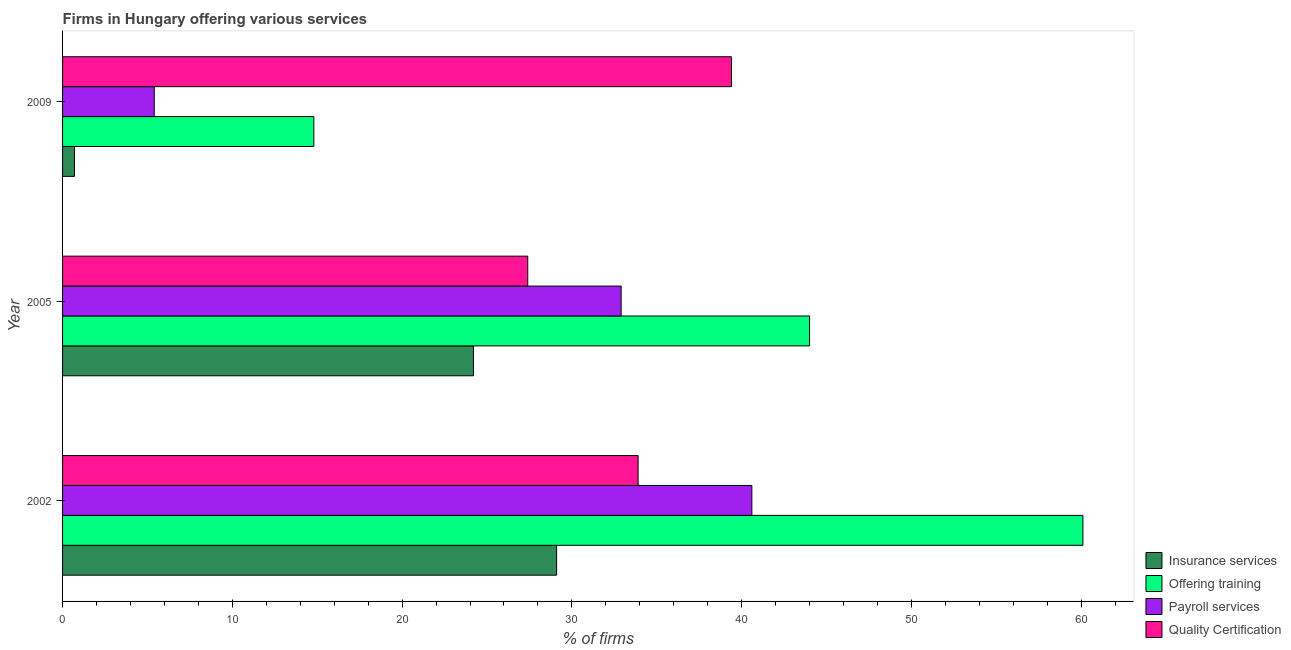How many different coloured bars are there?
Provide a short and direct response. 4. How many groups of bars are there?
Your answer should be very brief. 3. Are the number of bars per tick equal to the number of legend labels?
Your response must be concise. Yes. Are the number of bars on each tick of the Y-axis equal?
Your response must be concise. Yes. How many bars are there on the 1st tick from the top?
Ensure brevity in your answer.  4. How many bars are there on the 3rd tick from the bottom?
Give a very brief answer. 4. What is the label of the 1st group of bars from the top?
Keep it short and to the point. 2009. In how many cases, is the number of bars for a given year not equal to the number of legend labels?
Offer a very short reply. 0. What is the percentage of firms offering quality certification in 2005?
Give a very brief answer. 27.4. Across all years, what is the maximum percentage of firms offering insurance services?
Your answer should be compact. 29.1. Across all years, what is the minimum percentage of firms offering training?
Ensure brevity in your answer.  14.8. In which year was the percentage of firms offering insurance services minimum?
Your answer should be compact. 2009. What is the total percentage of firms offering quality certification in the graph?
Make the answer very short. 100.7. What is the difference between the percentage of firms offering quality certification in 2002 and that in 2009?
Make the answer very short. -5.5. What is the difference between the percentage of firms offering insurance services in 2005 and the percentage of firms offering payroll services in 2009?
Give a very brief answer. 18.8. What is the average percentage of firms offering quality certification per year?
Offer a terse response. 33.57. In the year 2009, what is the difference between the percentage of firms offering payroll services and percentage of firms offering quality certification?
Keep it short and to the point. -34. In how many years, is the percentage of firms offering quality certification greater than 46 %?
Make the answer very short. 0. What is the ratio of the percentage of firms offering insurance services in 2002 to that in 2005?
Provide a short and direct response. 1.2. What is the difference between the highest and the lowest percentage of firms offering quality certification?
Give a very brief answer. 12. Is the sum of the percentage of firms offering training in 2005 and 2009 greater than the maximum percentage of firms offering payroll services across all years?
Provide a succinct answer. Yes. Is it the case that in every year, the sum of the percentage of firms offering payroll services and percentage of firms offering training is greater than the sum of percentage of firms offering insurance services and percentage of firms offering quality certification?
Your answer should be compact. No. What does the 1st bar from the top in 2009 represents?
Your answer should be compact. Quality Certification. What does the 4th bar from the bottom in 2002 represents?
Ensure brevity in your answer.  Quality Certification. Is it the case that in every year, the sum of the percentage of firms offering insurance services and percentage of firms offering training is greater than the percentage of firms offering payroll services?
Ensure brevity in your answer.  Yes. How many bars are there?
Offer a very short reply. 12. How many years are there in the graph?
Provide a short and direct response. 3. Where does the legend appear in the graph?
Offer a terse response. Bottom right. How many legend labels are there?
Your answer should be very brief. 4. What is the title of the graph?
Provide a short and direct response. Firms in Hungary offering various services . What is the label or title of the X-axis?
Provide a short and direct response. % of firms. What is the % of firms of Insurance services in 2002?
Make the answer very short. 29.1. What is the % of firms of Offering training in 2002?
Make the answer very short. 60.1. What is the % of firms of Payroll services in 2002?
Provide a short and direct response. 40.6. What is the % of firms of Quality Certification in 2002?
Provide a succinct answer. 33.9. What is the % of firms in Insurance services in 2005?
Make the answer very short. 24.2. What is the % of firms in Offering training in 2005?
Your answer should be very brief. 44. What is the % of firms of Payroll services in 2005?
Provide a short and direct response. 32.9. What is the % of firms of Quality Certification in 2005?
Make the answer very short. 27.4. What is the % of firms of Offering training in 2009?
Ensure brevity in your answer.  14.8. What is the % of firms in Quality Certification in 2009?
Give a very brief answer. 39.4. Across all years, what is the maximum % of firms of Insurance services?
Make the answer very short. 29.1. Across all years, what is the maximum % of firms in Offering training?
Your answer should be very brief. 60.1. Across all years, what is the maximum % of firms in Payroll services?
Provide a short and direct response. 40.6. Across all years, what is the maximum % of firms in Quality Certification?
Your answer should be compact. 39.4. Across all years, what is the minimum % of firms in Payroll services?
Your answer should be compact. 5.4. Across all years, what is the minimum % of firms of Quality Certification?
Offer a very short reply. 27.4. What is the total % of firms in Insurance services in the graph?
Your answer should be very brief. 54. What is the total % of firms in Offering training in the graph?
Your response must be concise. 118.9. What is the total % of firms in Payroll services in the graph?
Ensure brevity in your answer.  78.9. What is the total % of firms in Quality Certification in the graph?
Keep it short and to the point. 100.7. What is the difference between the % of firms of Offering training in 2002 and that in 2005?
Ensure brevity in your answer.  16.1. What is the difference between the % of firms of Insurance services in 2002 and that in 2009?
Keep it short and to the point. 28.4. What is the difference between the % of firms in Offering training in 2002 and that in 2009?
Your answer should be very brief. 45.3. What is the difference between the % of firms of Payroll services in 2002 and that in 2009?
Keep it short and to the point. 35.2. What is the difference between the % of firms in Offering training in 2005 and that in 2009?
Keep it short and to the point. 29.2. What is the difference between the % of firms of Payroll services in 2005 and that in 2009?
Provide a short and direct response. 27.5. What is the difference between the % of firms of Quality Certification in 2005 and that in 2009?
Provide a succinct answer. -12. What is the difference between the % of firms in Insurance services in 2002 and the % of firms in Offering training in 2005?
Make the answer very short. -14.9. What is the difference between the % of firms in Offering training in 2002 and the % of firms in Payroll services in 2005?
Provide a succinct answer. 27.2. What is the difference between the % of firms in Offering training in 2002 and the % of firms in Quality Certification in 2005?
Provide a succinct answer. 32.7. What is the difference between the % of firms of Insurance services in 2002 and the % of firms of Offering training in 2009?
Provide a short and direct response. 14.3. What is the difference between the % of firms in Insurance services in 2002 and the % of firms in Payroll services in 2009?
Your answer should be very brief. 23.7. What is the difference between the % of firms in Offering training in 2002 and the % of firms in Payroll services in 2009?
Offer a terse response. 54.7. What is the difference between the % of firms of Offering training in 2002 and the % of firms of Quality Certification in 2009?
Ensure brevity in your answer.  20.7. What is the difference between the % of firms in Payroll services in 2002 and the % of firms in Quality Certification in 2009?
Ensure brevity in your answer.  1.2. What is the difference between the % of firms in Insurance services in 2005 and the % of firms in Offering training in 2009?
Offer a very short reply. 9.4. What is the difference between the % of firms of Insurance services in 2005 and the % of firms of Quality Certification in 2009?
Your answer should be compact. -15.2. What is the difference between the % of firms of Offering training in 2005 and the % of firms of Payroll services in 2009?
Your answer should be compact. 38.6. What is the difference between the % of firms of Payroll services in 2005 and the % of firms of Quality Certification in 2009?
Your response must be concise. -6.5. What is the average % of firms in Insurance services per year?
Your response must be concise. 18. What is the average % of firms of Offering training per year?
Offer a very short reply. 39.63. What is the average % of firms in Payroll services per year?
Ensure brevity in your answer.  26.3. What is the average % of firms in Quality Certification per year?
Offer a very short reply. 33.57. In the year 2002, what is the difference between the % of firms of Insurance services and % of firms of Offering training?
Provide a succinct answer. -31. In the year 2002, what is the difference between the % of firms in Insurance services and % of firms in Payroll services?
Ensure brevity in your answer.  -11.5. In the year 2002, what is the difference between the % of firms of Offering training and % of firms of Payroll services?
Your answer should be compact. 19.5. In the year 2002, what is the difference between the % of firms of Offering training and % of firms of Quality Certification?
Keep it short and to the point. 26.2. In the year 2002, what is the difference between the % of firms in Payroll services and % of firms in Quality Certification?
Offer a very short reply. 6.7. In the year 2005, what is the difference between the % of firms of Insurance services and % of firms of Offering training?
Offer a very short reply. -19.8. In the year 2009, what is the difference between the % of firms in Insurance services and % of firms in Offering training?
Offer a very short reply. -14.1. In the year 2009, what is the difference between the % of firms of Insurance services and % of firms of Quality Certification?
Your answer should be very brief. -38.7. In the year 2009, what is the difference between the % of firms in Offering training and % of firms in Quality Certification?
Provide a succinct answer. -24.6. In the year 2009, what is the difference between the % of firms in Payroll services and % of firms in Quality Certification?
Your answer should be compact. -34. What is the ratio of the % of firms in Insurance services in 2002 to that in 2005?
Give a very brief answer. 1.2. What is the ratio of the % of firms in Offering training in 2002 to that in 2005?
Provide a succinct answer. 1.37. What is the ratio of the % of firms of Payroll services in 2002 to that in 2005?
Your response must be concise. 1.23. What is the ratio of the % of firms of Quality Certification in 2002 to that in 2005?
Your answer should be very brief. 1.24. What is the ratio of the % of firms in Insurance services in 2002 to that in 2009?
Your answer should be compact. 41.57. What is the ratio of the % of firms in Offering training in 2002 to that in 2009?
Provide a succinct answer. 4.06. What is the ratio of the % of firms in Payroll services in 2002 to that in 2009?
Give a very brief answer. 7.52. What is the ratio of the % of firms in Quality Certification in 2002 to that in 2009?
Give a very brief answer. 0.86. What is the ratio of the % of firms in Insurance services in 2005 to that in 2009?
Your answer should be very brief. 34.57. What is the ratio of the % of firms in Offering training in 2005 to that in 2009?
Provide a succinct answer. 2.97. What is the ratio of the % of firms of Payroll services in 2005 to that in 2009?
Provide a short and direct response. 6.09. What is the ratio of the % of firms in Quality Certification in 2005 to that in 2009?
Your answer should be very brief. 0.7. What is the difference between the highest and the second highest % of firms of Insurance services?
Make the answer very short. 4.9. What is the difference between the highest and the lowest % of firms in Insurance services?
Provide a succinct answer. 28.4. What is the difference between the highest and the lowest % of firms of Offering training?
Give a very brief answer. 45.3. What is the difference between the highest and the lowest % of firms in Payroll services?
Offer a terse response. 35.2. 